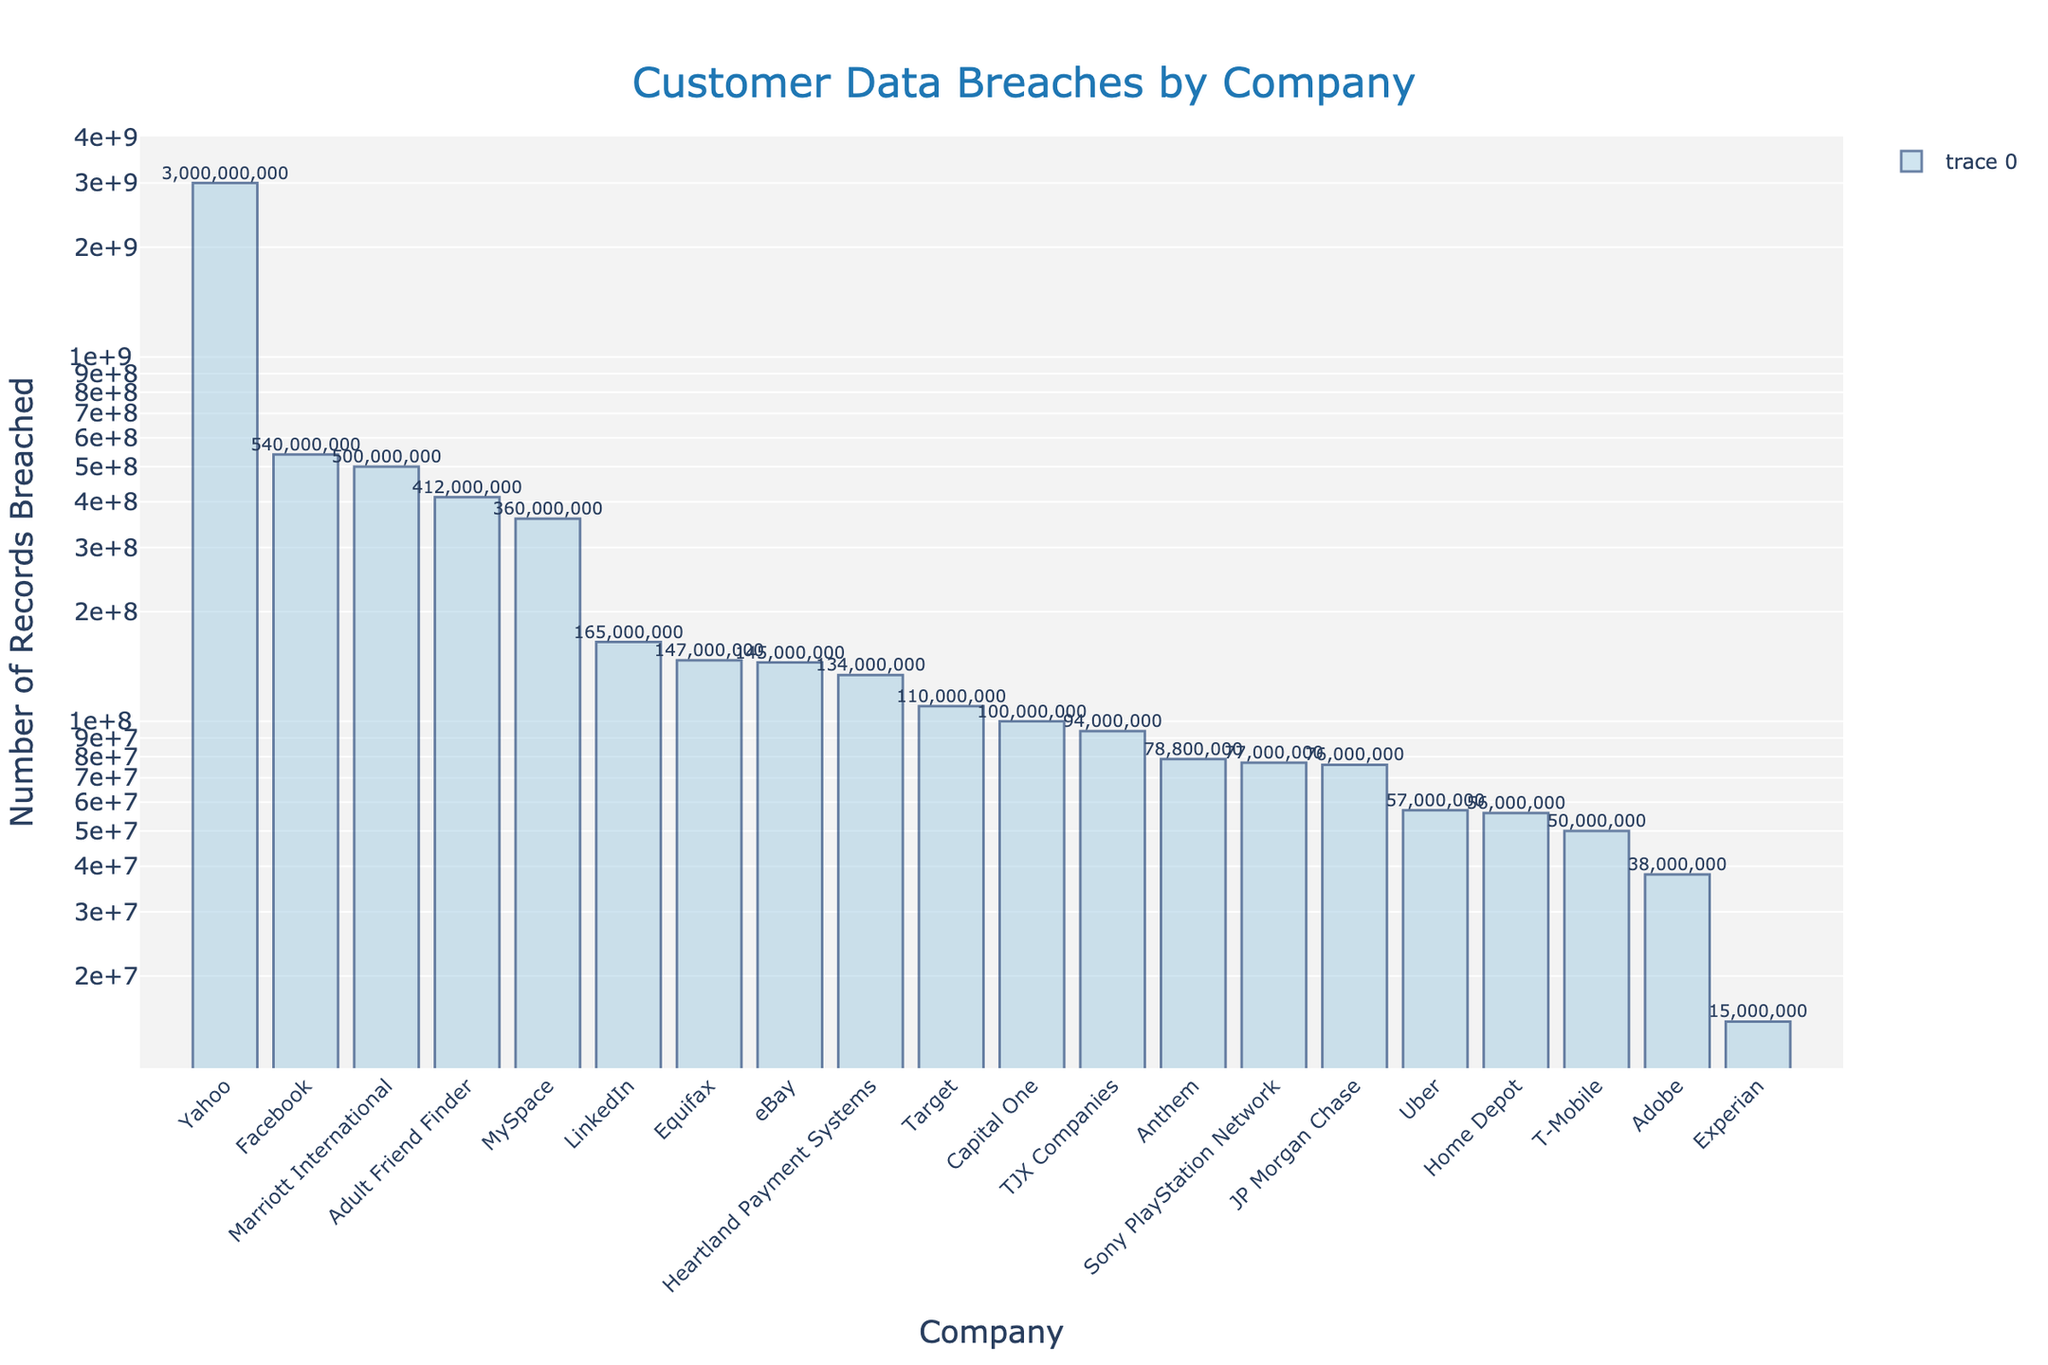Which company had the highest number of records breached? By observing the height of the bars, the bar associated with Yahoo is the tallest, indicating it has the highest number of records breached.
Answer: Yahoo What is the total number of records breached for Facebook, Marriott International, and Adult Friend Finder combined? Add the numbers of records breached for Facebook (540,000,000), Marriott International (500,000,000), and Adult Friend Finder (412,000,000). The total is 540,000,000 + 500,000,000 + 412,000,000 = 1,452,000,000.
Answer: 1,452,000,000 Among Target, Adobe, and Experian, which company had the fewest records breached? Compare the heights of the bars for Target, Adobe, and Experian. The bar for Experian is the shortest among the three, indicating it had the fewest records breached.
Answer: Experian How many more records were breached by Yahoo compared to MySpace? Subtract the number of records breached by MySpace (360,000,000) from the number of records breached by Yahoo (3,000,000,000). The difference is 3,000,000,000 - 360,000,000 = 2,640,000,000.
Answer: 2,640,000,000 What is the average number of records breached for Equifax, LinkedIn, and Capital One? Sum the numbers of records breached for Equifax (147,000,000), LinkedIn (165,000,000), and Capital One (100,000,000), then divide by 3. The sum is 147,000,000 + 165,000,000 + 100,000,000 = 412,000,000. The average is 412,000,000 / 3 ≈ 137,333,333.
Answer: 137,333,333 Which company had slightly more records breached: TJX Companies or Uber? Compare the heights of the bars for TJX Companies and Uber. The bar for TJX Companies is slightly taller, indicating it had more records breached.
Answer: TJX Companies How many records were breached by the top three companies combined? Add the numbers of records breached by Yahoo (3,000,000,000), Facebook (540,000,000), and Marriott International (500,000,000). The total is 3,000,000,000 + 540,000,000 + 500,000,000 = 4,040,000,000.
Answer: 4,040,000,000 What is the difference between the number of records breached by Sony PlayStation Network and Home Depot? Subtract the number of records breached by Home Depot (56,000,000) from the number of records breached by Sony PlayStation Network (77,000,000). The difference is 77,000,000 - 56,000,000 = 21,000,000.
Answer: 21,000,000 Which company had fewer records breached: Heartland Payment Systems or Anthem? Compare the heights of the bars for Heartland Payment Systems and Anthem. The bar for Anthem is shorter, indicating it had fewer records breached.
Answer: Anthem What is the median number of records breached for the companies listed? First, list the number of records breached in ascending order: 15,000,000, 38,000,000, 50,000,000, 56,000,000, 57,000,000, 77,000,000, 78,800,000, 76,000,000, 94,000,000, 100,000,000, 110,000,000, 134,000,000, 145,000,000, 147,000,000, 165,000,000, 360,000,000, 412,000,000, 500,000,000, 540,000,000, 3,000,000,000. The middle value (10th and 11th) is the median of 94,000,000 and 100,000,000, so the median number of records breached is 99,000,000.
Answer: 99,000,000 